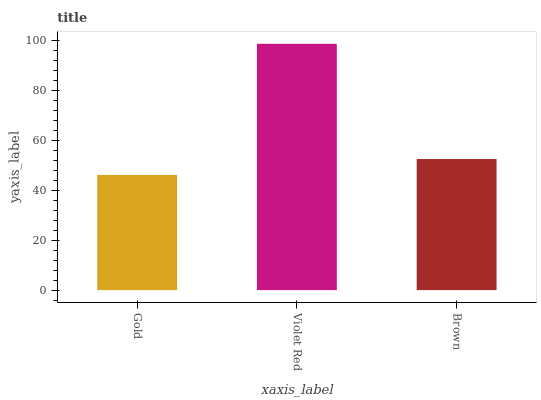Is Brown the minimum?
Answer yes or no. No. Is Brown the maximum?
Answer yes or no. No. Is Violet Red greater than Brown?
Answer yes or no. Yes. Is Brown less than Violet Red?
Answer yes or no. Yes. Is Brown greater than Violet Red?
Answer yes or no. No. Is Violet Red less than Brown?
Answer yes or no. No. Is Brown the high median?
Answer yes or no. Yes. Is Brown the low median?
Answer yes or no. Yes. Is Violet Red the high median?
Answer yes or no. No. Is Gold the low median?
Answer yes or no. No. 